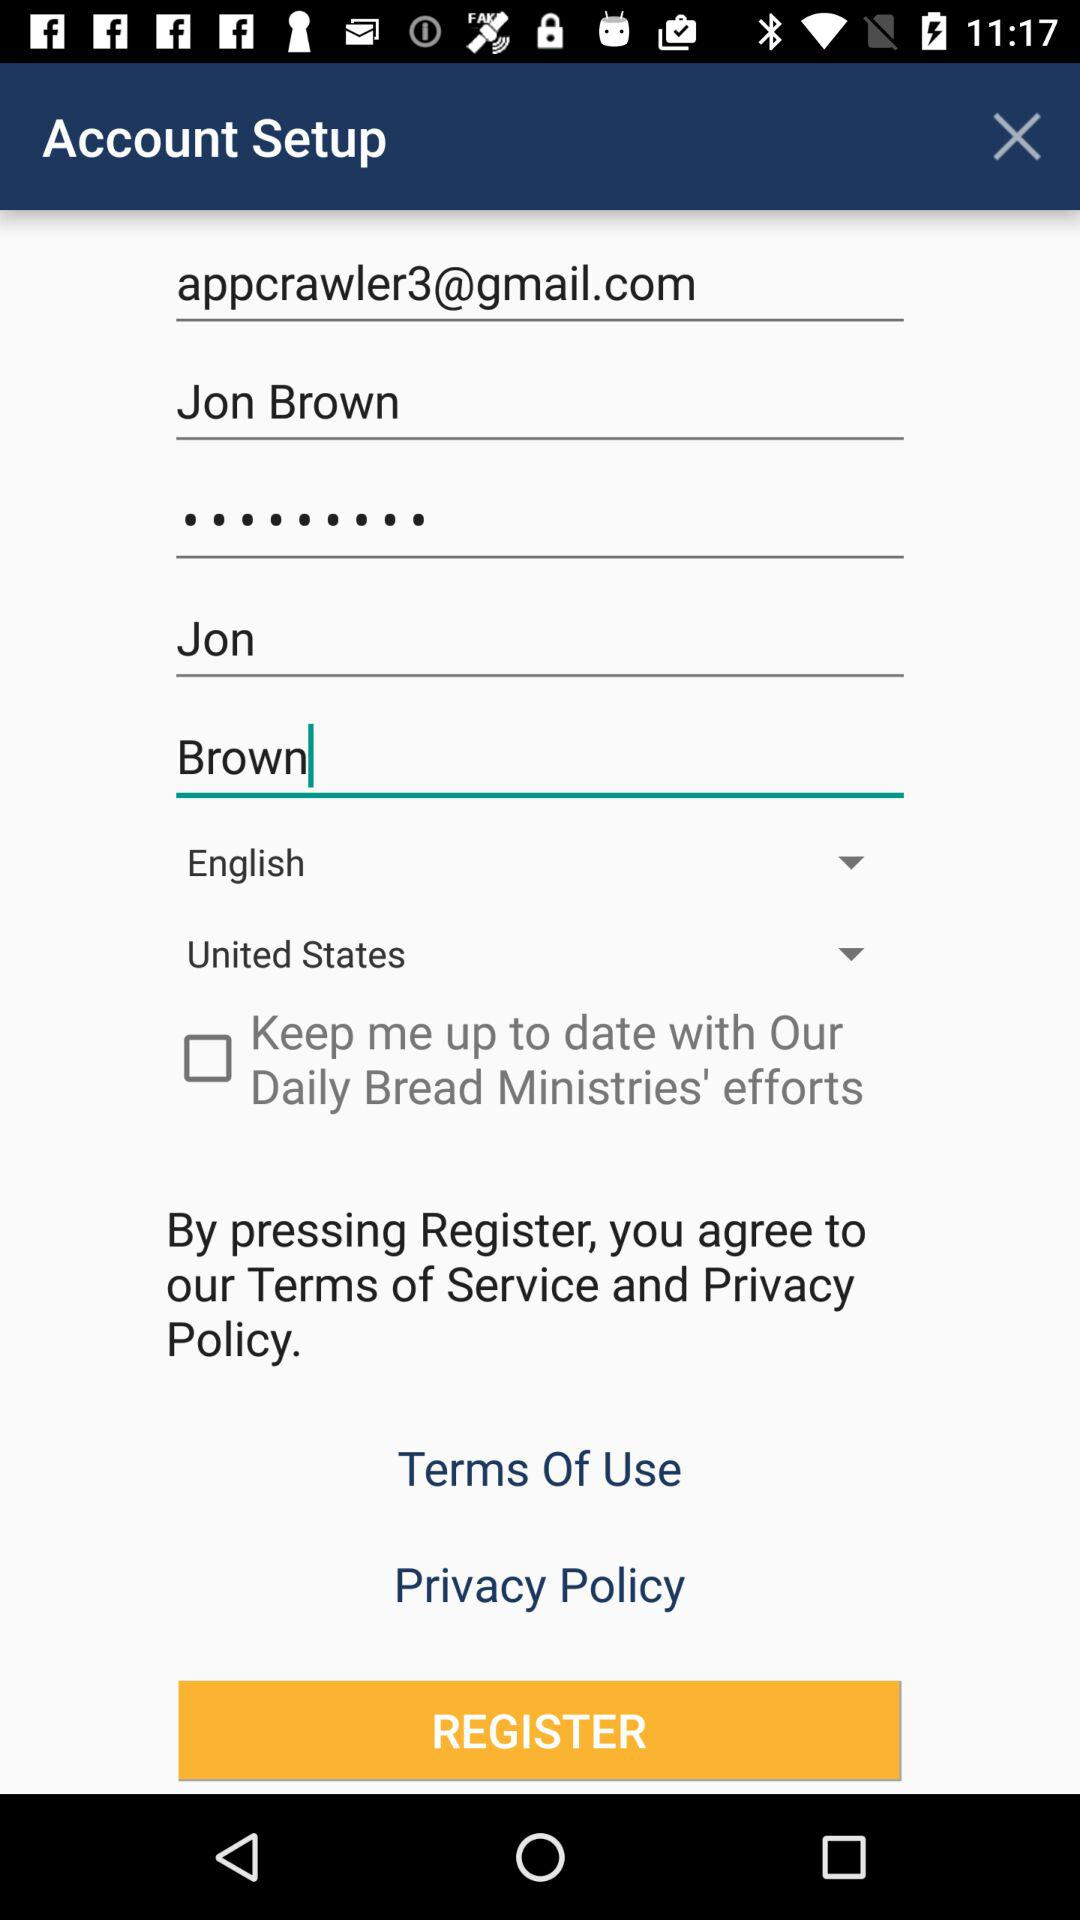Which language is selected? The selected language is English. 